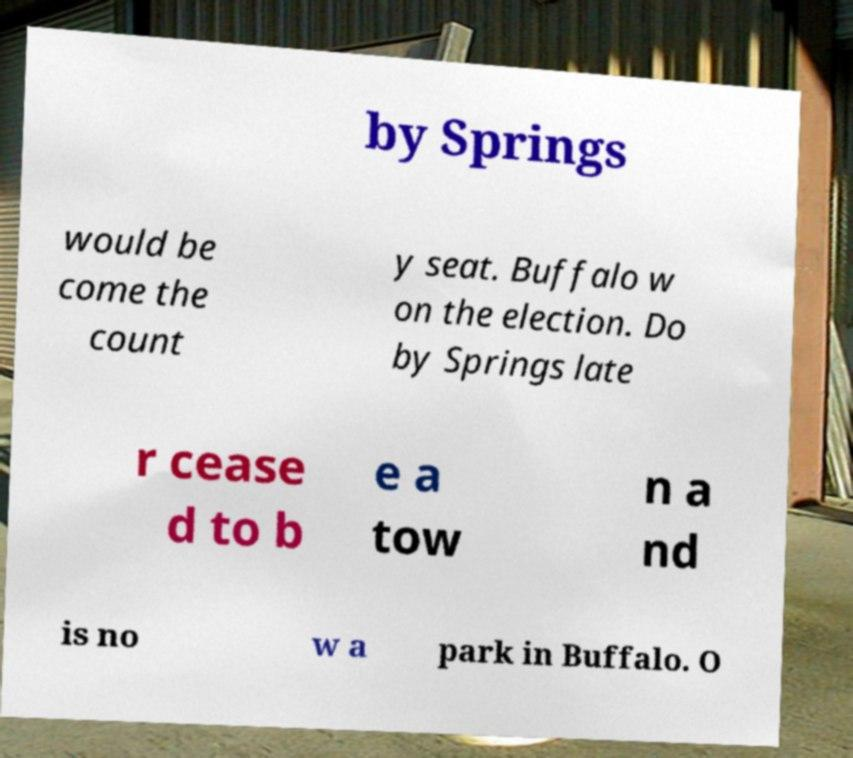Can you read and provide the text displayed in the image?This photo seems to have some interesting text. Can you extract and type it out for me? by Springs would be come the count y seat. Buffalo w on the election. Do by Springs late r cease d to b e a tow n a nd is no w a park in Buffalo. O 